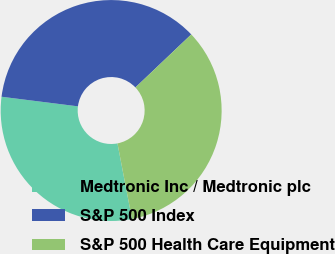Convert chart to OTSL. <chart><loc_0><loc_0><loc_500><loc_500><pie_chart><fcel>Medtronic Inc / Medtronic plc<fcel>S&P 500 Index<fcel>S&P 500 Health Care Equipment<nl><fcel>30.01%<fcel>35.92%<fcel>34.07%<nl></chart> 